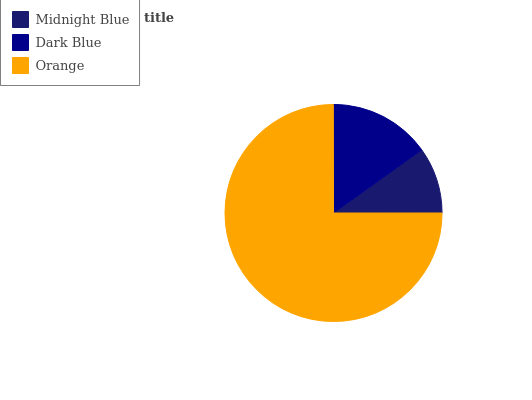Is Midnight Blue the minimum?
Answer yes or no. Yes. Is Orange the maximum?
Answer yes or no. Yes. Is Dark Blue the minimum?
Answer yes or no. No. Is Dark Blue the maximum?
Answer yes or no. No. Is Dark Blue greater than Midnight Blue?
Answer yes or no. Yes. Is Midnight Blue less than Dark Blue?
Answer yes or no. Yes. Is Midnight Blue greater than Dark Blue?
Answer yes or no. No. Is Dark Blue less than Midnight Blue?
Answer yes or no. No. Is Dark Blue the high median?
Answer yes or no. Yes. Is Dark Blue the low median?
Answer yes or no. Yes. Is Orange the high median?
Answer yes or no. No. Is Midnight Blue the low median?
Answer yes or no. No. 